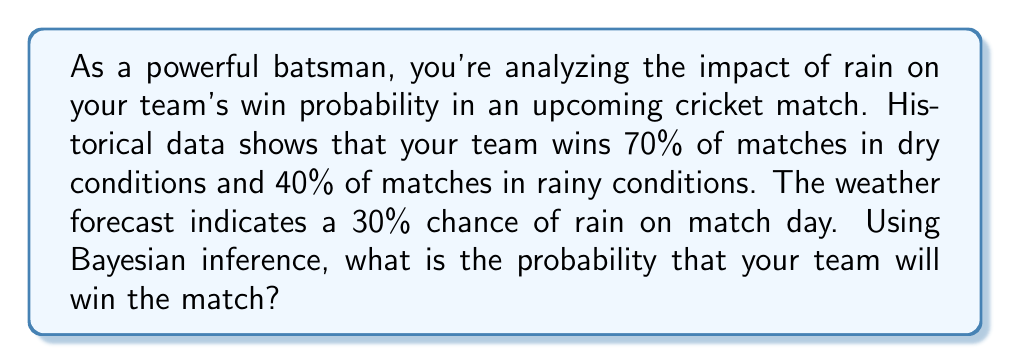What is the answer to this math problem? Let's approach this step-by-step using Bayesian inference:

1) Define our events:
   W: Team wins
   R: It rains

2) Given probabilities:
   P(W|R) = 0.40 (probability of winning given it rains)
   P(W|not R) = 0.70 (probability of winning given it doesn't rain)
   P(R) = 0.30 (probability of rain)

3) Calculate P(not R):
   P(not R) = 1 - P(R) = 1 - 0.30 = 0.70

4) Use the law of total probability to find P(W):
   $$P(W) = P(W|R) \cdot P(R) + P(W|not R) \cdot P(not R)$$
   $$P(W) = 0.40 \cdot 0.30 + 0.70 \cdot 0.70$$
   $$P(W) = 0.12 + 0.49 = 0.61$$

Therefore, the probability that your team will win the match is 0.61 or 61%.
Answer: 0.61 